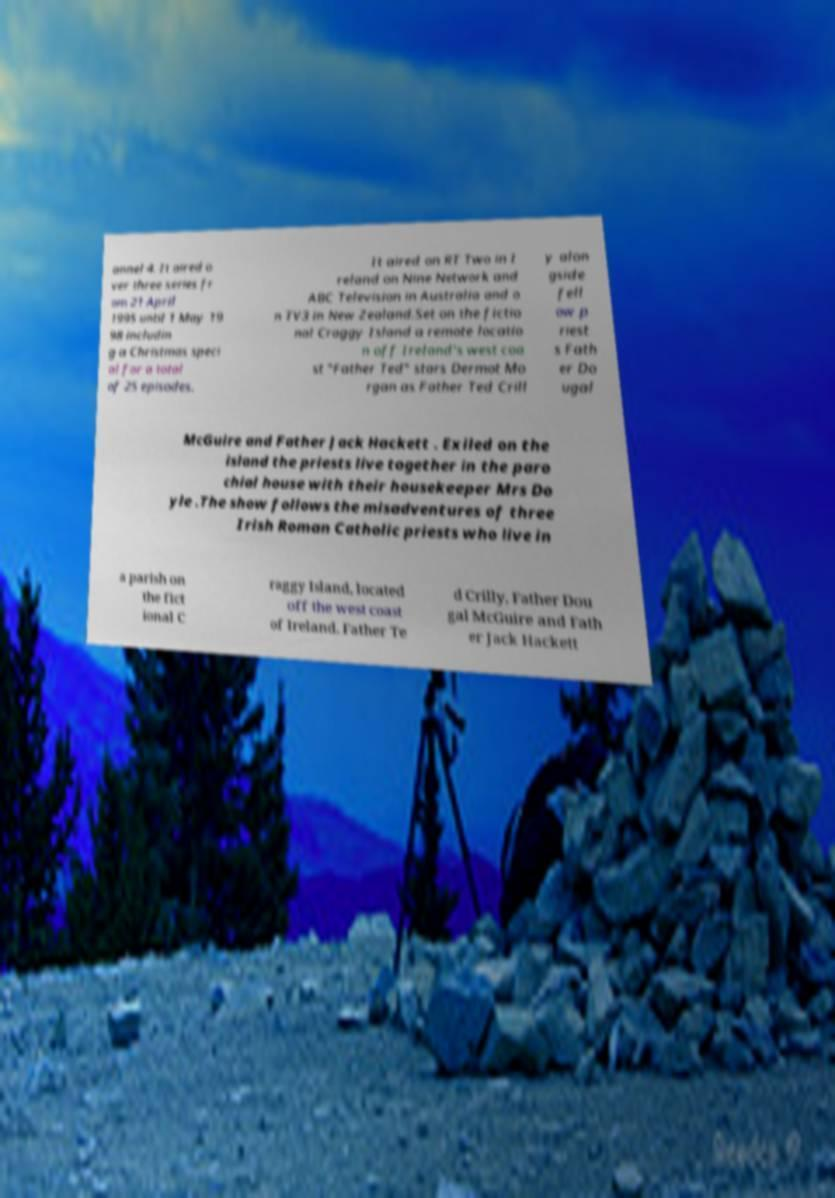For documentation purposes, I need the text within this image transcribed. Could you provide that? annel 4. It aired o ver three series fr om 21 April 1995 until 1 May 19 98 includin g a Christmas speci al for a total of 25 episodes. It aired on RT Two in I reland on Nine Network and ABC Television in Australia and o n TV3 in New Zealand.Set on the fictio nal Craggy Island a remote locatio n off Ireland's west coa st "Father Ted" stars Dermot Mo rgan as Father Ted Crill y alon gside fell ow p riest s Fath er Do ugal McGuire and Father Jack Hackett . Exiled on the island the priests live together in the paro chial house with their housekeeper Mrs Do yle .The show follows the misadventures of three Irish Roman Catholic priests who live in a parish on the fict ional C raggy Island, located off the west coast of Ireland. Father Te d Crilly, Father Dou gal McGuire and Fath er Jack Hackett 